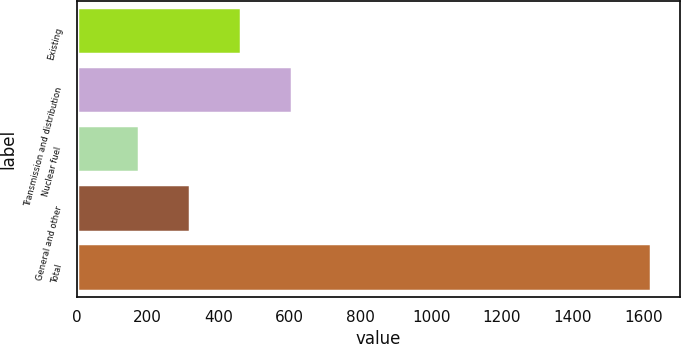<chart> <loc_0><loc_0><loc_500><loc_500><bar_chart><fcel>Existing<fcel>Transmission and distribution<fcel>Nuclear fuel<fcel>General and other<fcel>Total<nl><fcel>464<fcel>608.5<fcel>175<fcel>319.5<fcel>1620<nl></chart> 